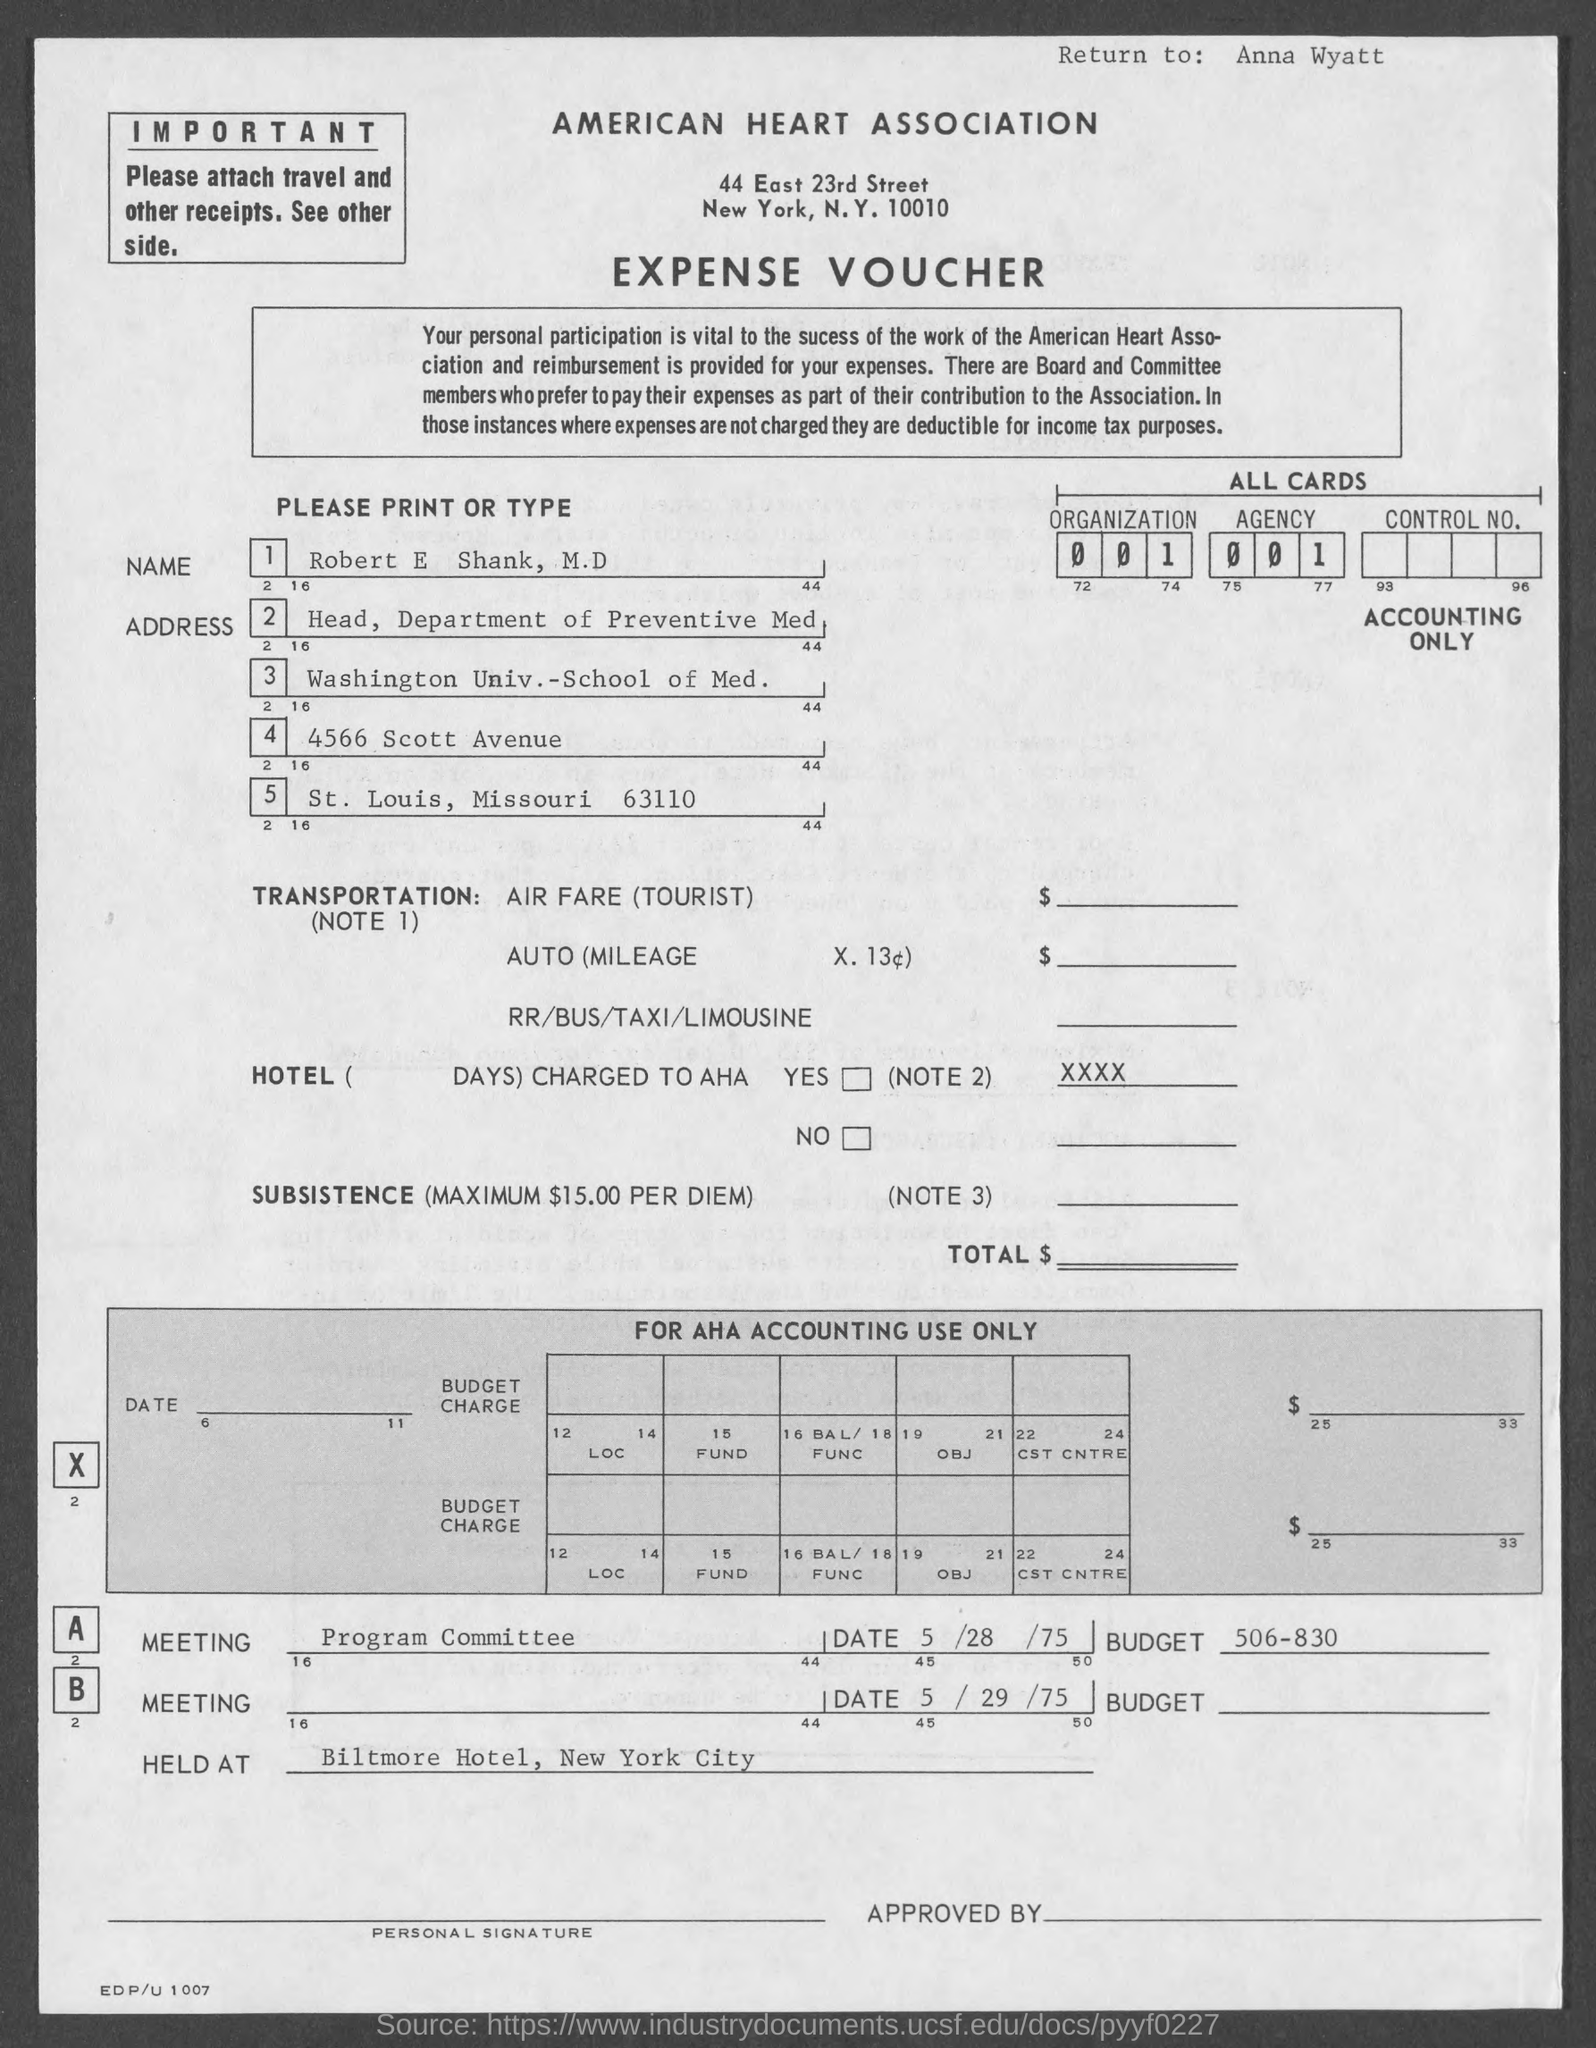Highlight a few significant elements in this photo. The American Heart Association is located in New York City. The Washington University School of Medicine is located in the state of Missouri. 